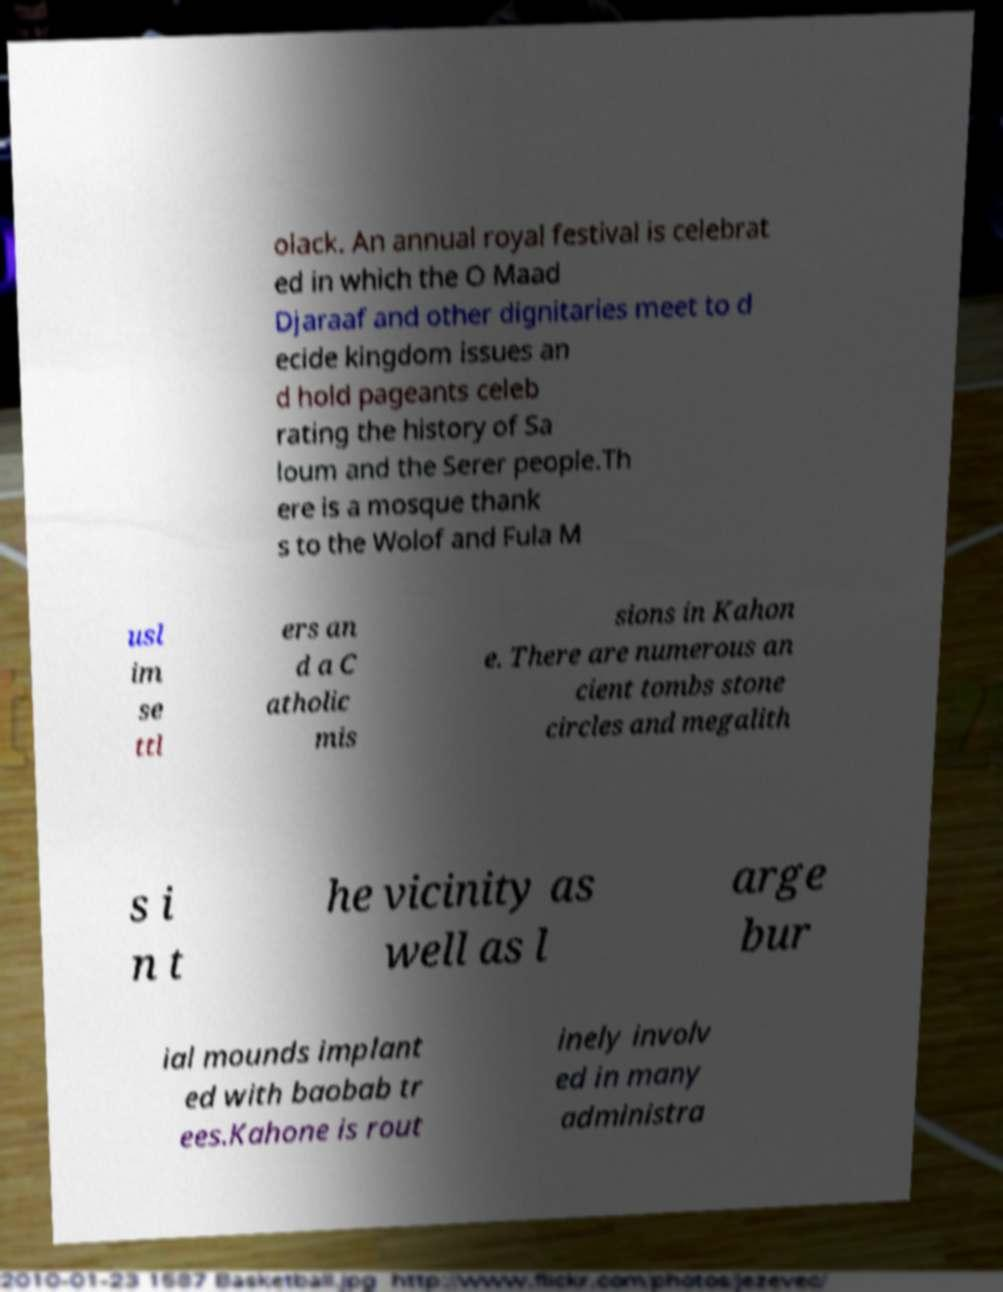Please read and relay the text visible in this image. What does it say? olack. An annual royal festival is celebrat ed in which the O Maad Djaraaf and other dignitaries meet to d ecide kingdom issues an d hold pageants celeb rating the history of Sa loum and the Serer people.Th ere is a mosque thank s to the Wolof and Fula M usl im se ttl ers an d a C atholic mis sions in Kahon e. There are numerous an cient tombs stone circles and megalith s i n t he vicinity as well as l arge bur ial mounds implant ed with baobab tr ees.Kahone is rout inely involv ed in many administra 